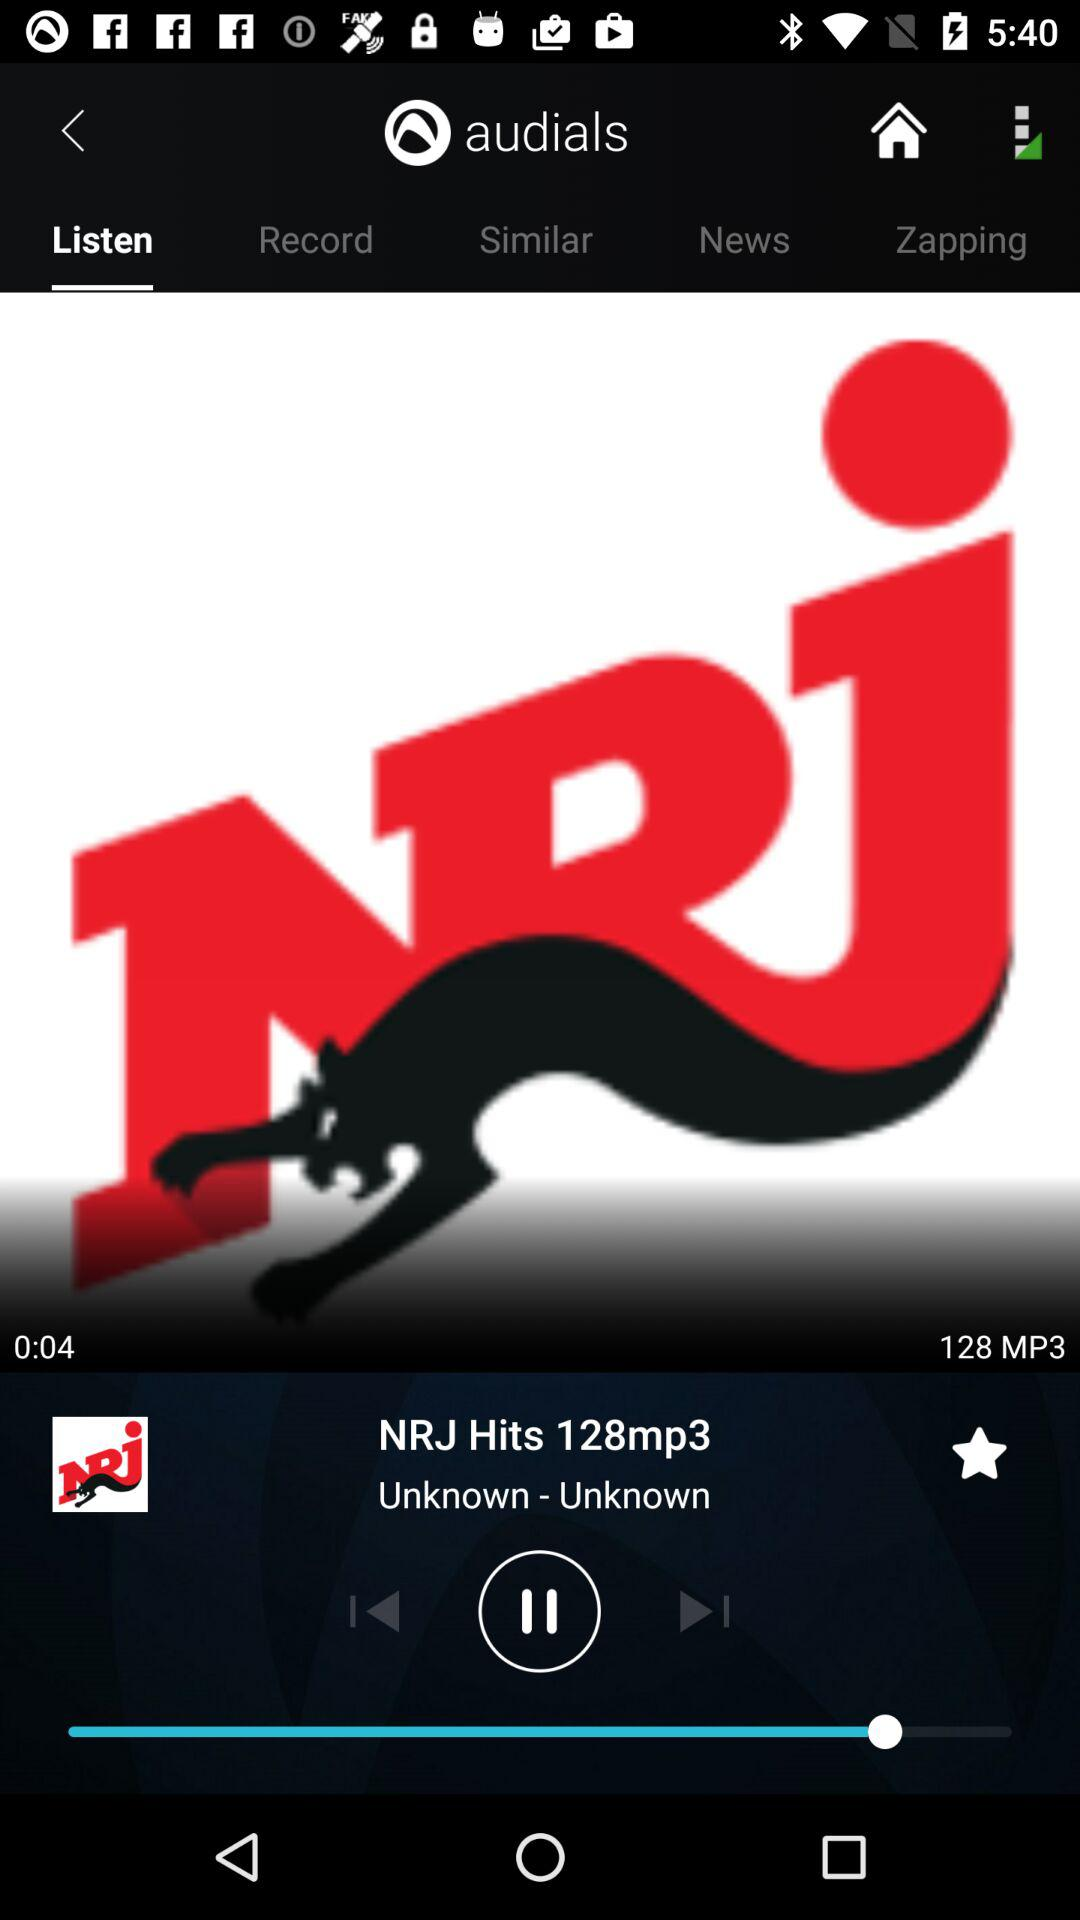How many more seconds are there than minutes in the current song duration?
Answer the question using a single word or phrase. 4 